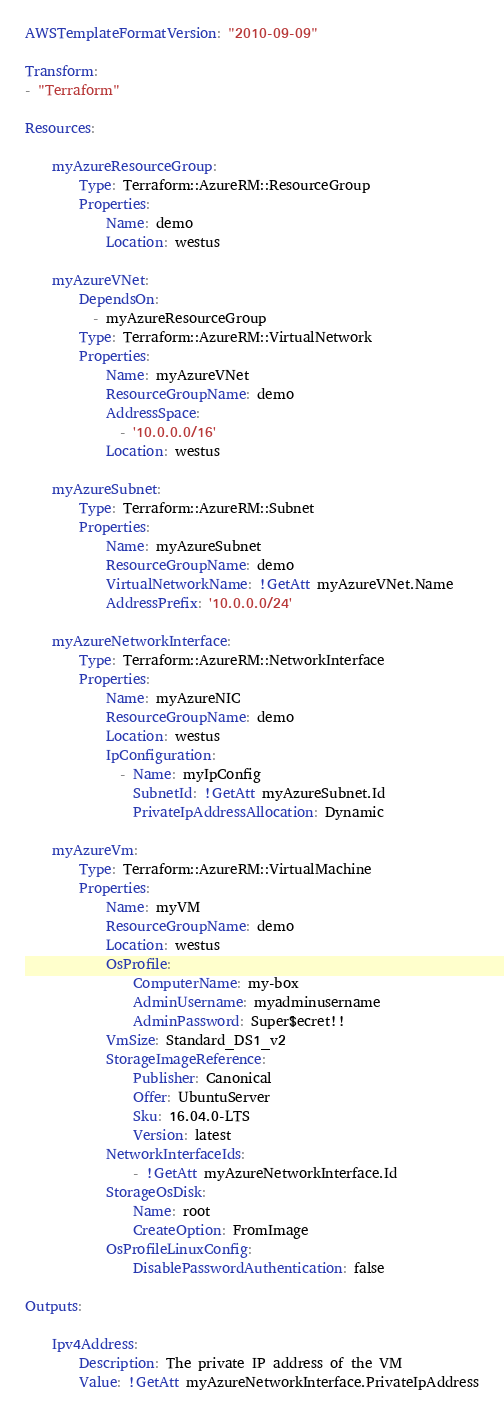<code> <loc_0><loc_0><loc_500><loc_500><_YAML_>AWSTemplateFormatVersion: "2010-09-09"

Transform:
- "Terraform"

Resources:

    myAzureResourceGroup:
        Type: Terraform::AzureRM::ResourceGroup
        Properties:
            Name: demo
            Location: westus

    myAzureVNet:
        DependsOn:
          - myAzureResourceGroup
        Type: Terraform::AzureRM::VirtualNetwork
        Properties:
            Name: myAzureVNet
            ResourceGroupName: demo
            AddressSpace:
              - '10.0.0.0/16'
            Location: westus

    myAzureSubnet:
        Type: Terraform::AzureRM::Subnet
        Properties:
            Name: myAzureSubnet
            ResourceGroupName: demo
            VirtualNetworkName: !GetAtt myAzureVNet.Name
            AddressPrefix: '10.0.0.0/24'

    myAzureNetworkInterface:
        Type: Terraform::AzureRM::NetworkInterface
        Properties:
            Name: myAzureNIC
            ResourceGroupName: demo
            Location: westus
            IpConfiguration:
              - Name: myIpConfig
                SubnetId: !GetAtt myAzureSubnet.Id
                PrivateIpAddressAllocation: Dynamic

    myAzureVm:
        Type: Terraform::AzureRM::VirtualMachine
        Properties:
            Name: myVM
            ResourceGroupName: demo
            Location: westus
            OsProfile:
                ComputerName: my-box
                AdminUsername: myadminusername
                AdminPassword: Super$ecret!!
            VmSize: Standard_DS1_v2
            StorageImageReference:
                Publisher: Canonical
                Offer: UbuntuServer
                Sku: 16.04.0-LTS
                Version: latest
            NetworkInterfaceIds:
                - !GetAtt myAzureNetworkInterface.Id
            StorageOsDisk:
                Name: root
                CreateOption: FromImage
            OsProfileLinuxConfig:
                DisablePasswordAuthentication: false

Outputs:

    Ipv4Address:
        Description: The private IP address of the VM
        Value: !GetAtt myAzureNetworkInterface.PrivateIpAddress
</code> 